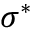Convert formula to latex. <formula><loc_0><loc_0><loc_500><loc_500>\sigma ^ { \ast }</formula> 